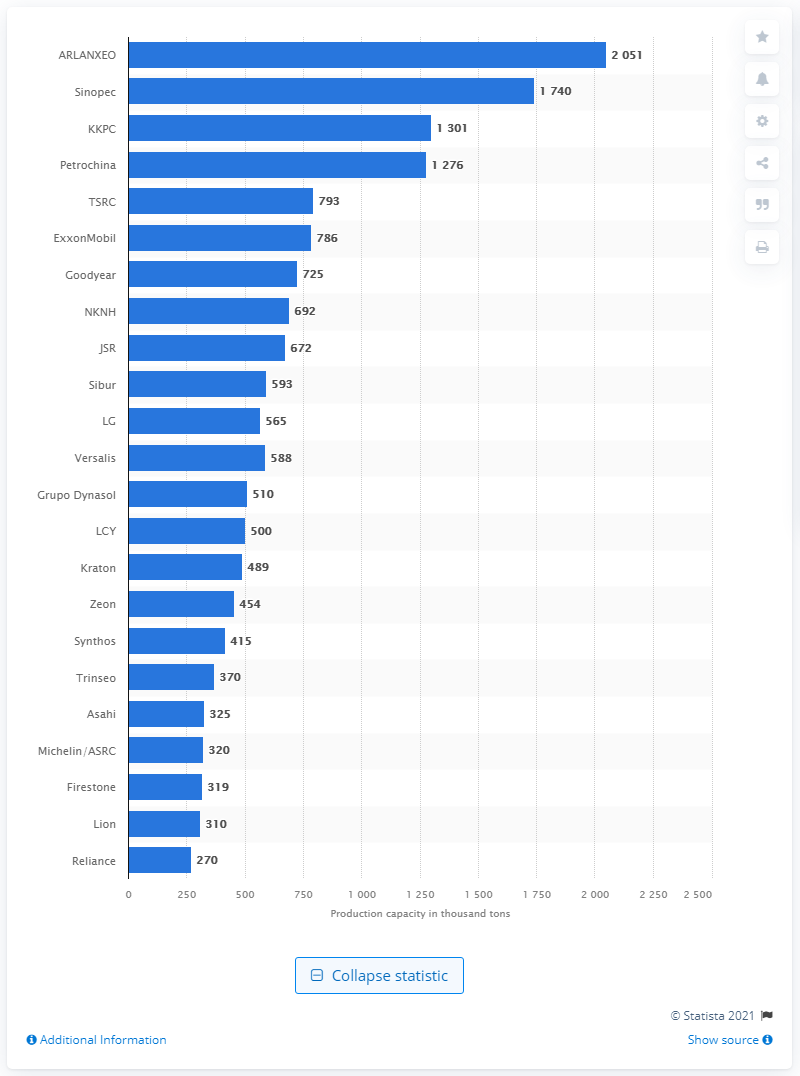Give some essential details in this illustration. In 2016, Sinopec was the second largest producer of synthetic rubber in the world. 